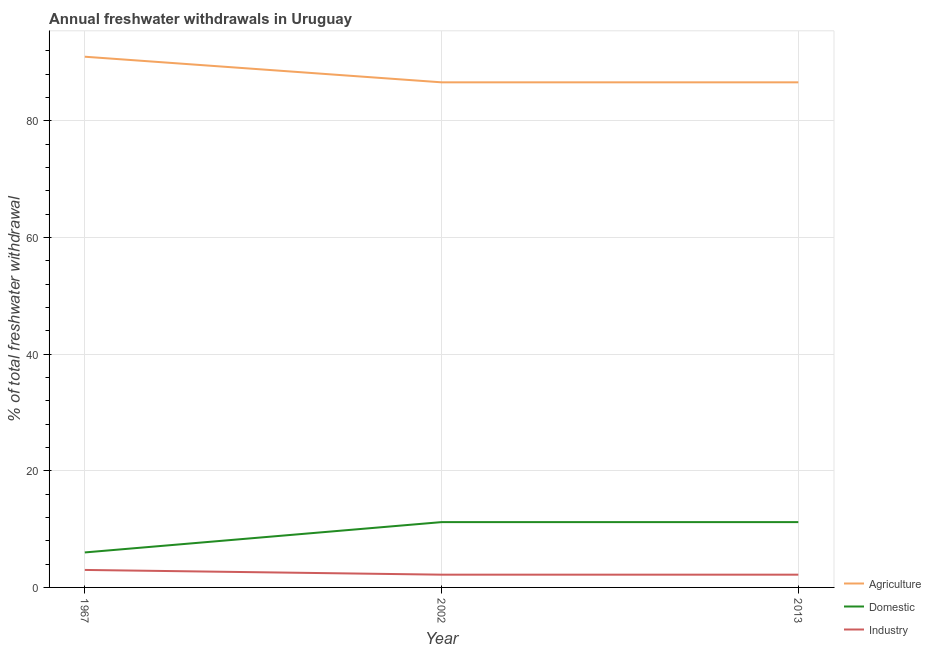How many different coloured lines are there?
Give a very brief answer. 3. Does the line corresponding to percentage of freshwater withdrawal for domestic purposes intersect with the line corresponding to percentage of freshwater withdrawal for industry?
Ensure brevity in your answer.  No. Is the number of lines equal to the number of legend labels?
Your response must be concise. Yes. Across all years, what is the maximum percentage of freshwater withdrawal for industry?
Provide a short and direct response. 3. Across all years, what is the minimum percentage of freshwater withdrawal for industry?
Provide a succinct answer. 2.19. What is the total percentage of freshwater withdrawal for agriculture in the graph?
Your response must be concise. 264.22. What is the difference between the percentage of freshwater withdrawal for agriculture in 1967 and that in 2002?
Keep it short and to the point. 4.39. What is the difference between the percentage of freshwater withdrawal for domestic purposes in 1967 and the percentage of freshwater withdrawal for industry in 2002?
Ensure brevity in your answer.  3.81. What is the average percentage of freshwater withdrawal for agriculture per year?
Your answer should be compact. 88.07. In the year 1967, what is the difference between the percentage of freshwater withdrawal for agriculture and percentage of freshwater withdrawal for domestic purposes?
Offer a terse response. 85. In how many years, is the percentage of freshwater withdrawal for agriculture greater than 72 %?
Keep it short and to the point. 3. What is the ratio of the percentage of freshwater withdrawal for industry in 1967 to that in 2013?
Offer a very short reply. 1.37. Is the difference between the percentage of freshwater withdrawal for domestic purposes in 1967 and 2013 greater than the difference between the percentage of freshwater withdrawal for agriculture in 1967 and 2013?
Keep it short and to the point. No. What is the difference between the highest and the second highest percentage of freshwater withdrawal for domestic purposes?
Offer a terse response. 0. What is the difference between the highest and the lowest percentage of freshwater withdrawal for industry?
Make the answer very short. 0.81. Is it the case that in every year, the sum of the percentage of freshwater withdrawal for agriculture and percentage of freshwater withdrawal for domestic purposes is greater than the percentage of freshwater withdrawal for industry?
Keep it short and to the point. Yes. Is the percentage of freshwater withdrawal for domestic purposes strictly greater than the percentage of freshwater withdrawal for agriculture over the years?
Make the answer very short. No. Is the percentage of freshwater withdrawal for industry strictly less than the percentage of freshwater withdrawal for agriculture over the years?
Your response must be concise. Yes. How many lines are there?
Your response must be concise. 3. Where does the legend appear in the graph?
Your answer should be compact. Bottom right. How many legend labels are there?
Offer a very short reply. 3. How are the legend labels stacked?
Offer a very short reply. Vertical. What is the title of the graph?
Offer a very short reply. Annual freshwater withdrawals in Uruguay. Does "Tertiary education" appear as one of the legend labels in the graph?
Make the answer very short. No. What is the label or title of the X-axis?
Give a very brief answer. Year. What is the label or title of the Y-axis?
Your answer should be very brief. % of total freshwater withdrawal. What is the % of total freshwater withdrawal in Agriculture in 1967?
Ensure brevity in your answer.  91. What is the % of total freshwater withdrawal in Industry in 1967?
Your response must be concise. 3. What is the % of total freshwater withdrawal of Agriculture in 2002?
Ensure brevity in your answer.  86.61. What is the % of total freshwater withdrawal of Domestic in 2002?
Provide a succinct answer. 11.2. What is the % of total freshwater withdrawal of Industry in 2002?
Offer a terse response. 2.19. What is the % of total freshwater withdrawal in Agriculture in 2013?
Provide a succinct answer. 86.61. What is the % of total freshwater withdrawal in Industry in 2013?
Your answer should be very brief. 2.19. Across all years, what is the maximum % of total freshwater withdrawal in Agriculture?
Keep it short and to the point. 91. Across all years, what is the maximum % of total freshwater withdrawal in Industry?
Keep it short and to the point. 3. Across all years, what is the minimum % of total freshwater withdrawal in Agriculture?
Provide a succinct answer. 86.61. Across all years, what is the minimum % of total freshwater withdrawal in Industry?
Ensure brevity in your answer.  2.19. What is the total % of total freshwater withdrawal in Agriculture in the graph?
Ensure brevity in your answer.  264.22. What is the total % of total freshwater withdrawal in Domestic in the graph?
Provide a succinct answer. 28.4. What is the total % of total freshwater withdrawal in Industry in the graph?
Give a very brief answer. 7.37. What is the difference between the % of total freshwater withdrawal in Agriculture in 1967 and that in 2002?
Provide a short and direct response. 4.39. What is the difference between the % of total freshwater withdrawal in Domestic in 1967 and that in 2002?
Offer a terse response. -5.2. What is the difference between the % of total freshwater withdrawal of Industry in 1967 and that in 2002?
Your answer should be very brief. 0.81. What is the difference between the % of total freshwater withdrawal in Agriculture in 1967 and that in 2013?
Keep it short and to the point. 4.39. What is the difference between the % of total freshwater withdrawal in Industry in 1967 and that in 2013?
Provide a short and direct response. 0.81. What is the difference between the % of total freshwater withdrawal in Agriculture in 2002 and that in 2013?
Offer a terse response. 0. What is the difference between the % of total freshwater withdrawal of Agriculture in 1967 and the % of total freshwater withdrawal of Domestic in 2002?
Make the answer very short. 79.8. What is the difference between the % of total freshwater withdrawal of Agriculture in 1967 and the % of total freshwater withdrawal of Industry in 2002?
Give a very brief answer. 88.81. What is the difference between the % of total freshwater withdrawal in Domestic in 1967 and the % of total freshwater withdrawal in Industry in 2002?
Give a very brief answer. 3.81. What is the difference between the % of total freshwater withdrawal of Agriculture in 1967 and the % of total freshwater withdrawal of Domestic in 2013?
Provide a succinct answer. 79.8. What is the difference between the % of total freshwater withdrawal of Agriculture in 1967 and the % of total freshwater withdrawal of Industry in 2013?
Keep it short and to the point. 88.81. What is the difference between the % of total freshwater withdrawal of Domestic in 1967 and the % of total freshwater withdrawal of Industry in 2013?
Ensure brevity in your answer.  3.81. What is the difference between the % of total freshwater withdrawal in Agriculture in 2002 and the % of total freshwater withdrawal in Domestic in 2013?
Your answer should be very brief. 75.41. What is the difference between the % of total freshwater withdrawal of Agriculture in 2002 and the % of total freshwater withdrawal of Industry in 2013?
Provide a succinct answer. 84.42. What is the difference between the % of total freshwater withdrawal in Domestic in 2002 and the % of total freshwater withdrawal in Industry in 2013?
Provide a short and direct response. 9.01. What is the average % of total freshwater withdrawal of Agriculture per year?
Make the answer very short. 88.07. What is the average % of total freshwater withdrawal of Domestic per year?
Offer a terse response. 9.47. What is the average % of total freshwater withdrawal of Industry per year?
Provide a succinct answer. 2.46. In the year 1967, what is the difference between the % of total freshwater withdrawal in Domestic and % of total freshwater withdrawal in Industry?
Offer a terse response. 3. In the year 2002, what is the difference between the % of total freshwater withdrawal of Agriculture and % of total freshwater withdrawal of Domestic?
Provide a succinct answer. 75.41. In the year 2002, what is the difference between the % of total freshwater withdrawal in Agriculture and % of total freshwater withdrawal in Industry?
Provide a short and direct response. 84.42. In the year 2002, what is the difference between the % of total freshwater withdrawal in Domestic and % of total freshwater withdrawal in Industry?
Give a very brief answer. 9.01. In the year 2013, what is the difference between the % of total freshwater withdrawal in Agriculture and % of total freshwater withdrawal in Domestic?
Your answer should be compact. 75.41. In the year 2013, what is the difference between the % of total freshwater withdrawal in Agriculture and % of total freshwater withdrawal in Industry?
Make the answer very short. 84.42. In the year 2013, what is the difference between the % of total freshwater withdrawal in Domestic and % of total freshwater withdrawal in Industry?
Make the answer very short. 9.01. What is the ratio of the % of total freshwater withdrawal in Agriculture in 1967 to that in 2002?
Make the answer very short. 1.05. What is the ratio of the % of total freshwater withdrawal in Domestic in 1967 to that in 2002?
Offer a terse response. 0.54. What is the ratio of the % of total freshwater withdrawal in Industry in 1967 to that in 2002?
Provide a succinct answer. 1.37. What is the ratio of the % of total freshwater withdrawal of Agriculture in 1967 to that in 2013?
Ensure brevity in your answer.  1.05. What is the ratio of the % of total freshwater withdrawal of Domestic in 1967 to that in 2013?
Your answer should be compact. 0.54. What is the ratio of the % of total freshwater withdrawal of Industry in 1967 to that in 2013?
Ensure brevity in your answer.  1.37. What is the ratio of the % of total freshwater withdrawal in Agriculture in 2002 to that in 2013?
Make the answer very short. 1. What is the ratio of the % of total freshwater withdrawal of Domestic in 2002 to that in 2013?
Provide a short and direct response. 1. What is the difference between the highest and the second highest % of total freshwater withdrawal of Agriculture?
Provide a short and direct response. 4.39. What is the difference between the highest and the second highest % of total freshwater withdrawal in Industry?
Ensure brevity in your answer.  0.81. What is the difference between the highest and the lowest % of total freshwater withdrawal of Agriculture?
Offer a terse response. 4.39. What is the difference between the highest and the lowest % of total freshwater withdrawal of Domestic?
Make the answer very short. 5.2. What is the difference between the highest and the lowest % of total freshwater withdrawal in Industry?
Your response must be concise. 0.81. 